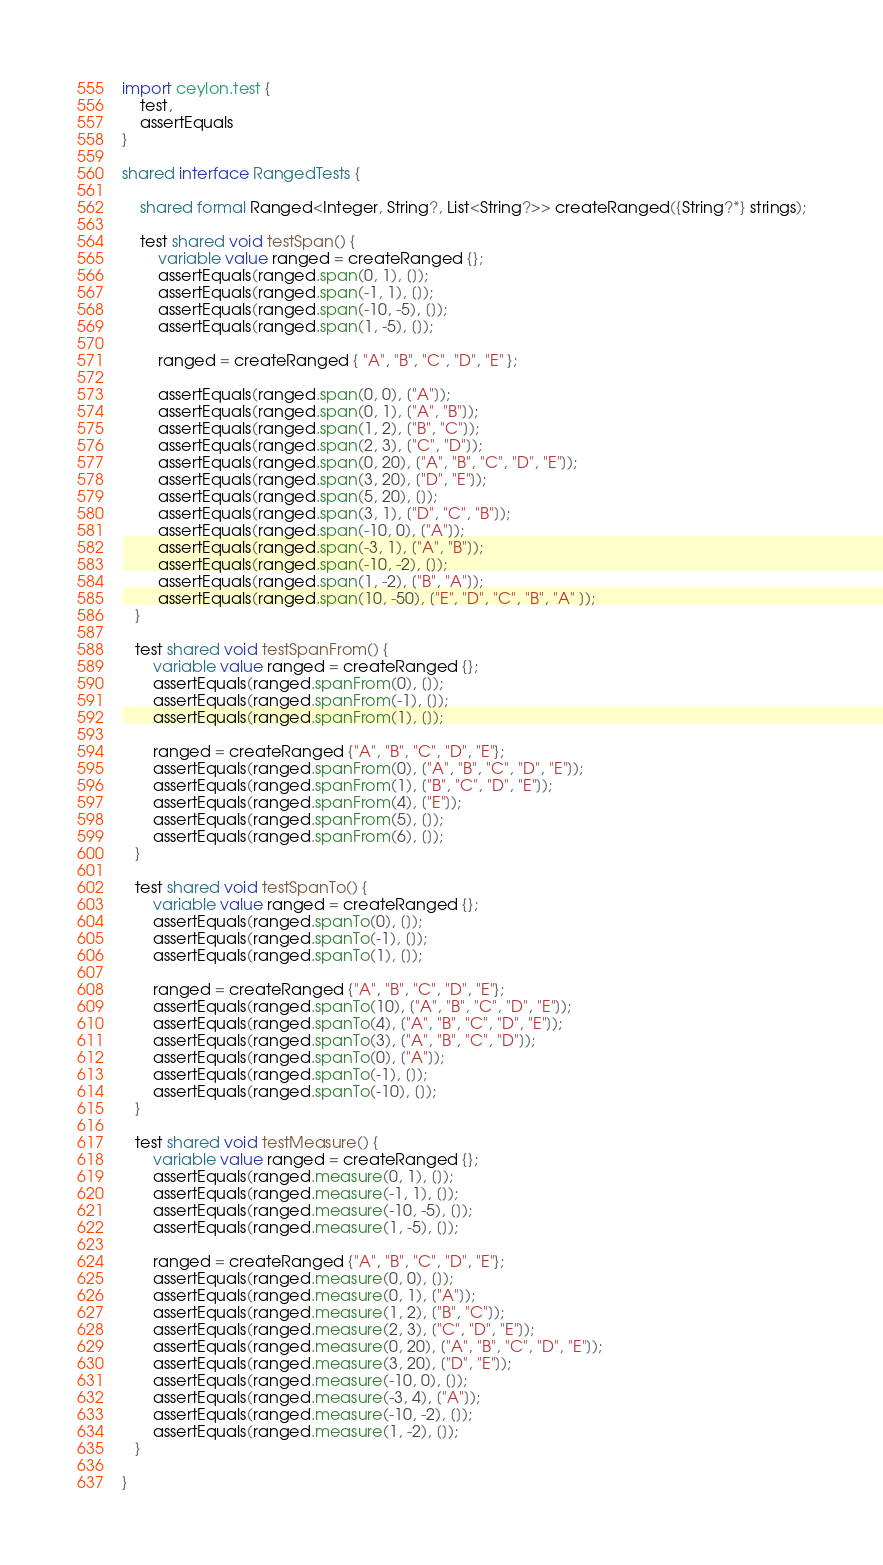Convert code to text. <code><loc_0><loc_0><loc_500><loc_500><_Ceylon_>import ceylon.test {
    test,
    assertEquals
}

shared interface RangedTests {

    shared formal Ranged<Integer, String?, List<String?>> createRanged({String?*} strings);

    test shared void testSpan() {
        variable value ranged = createRanged {};
        assertEquals(ranged.span(0, 1), []);
        assertEquals(ranged.span(-1, 1), []);
        assertEquals(ranged.span(-10, -5), []);
        assertEquals(ranged.span(1, -5), []);

        ranged = createRanged { "A", "B", "C", "D", "E" };

        assertEquals(ranged.span(0, 0), ["A"]);
        assertEquals(ranged.span(0, 1), ["A", "B"]);
        assertEquals(ranged.span(1, 2), ["B", "C"]);
        assertEquals(ranged.span(2, 3), ["C", "D"]);
        assertEquals(ranged.span(0, 20), ["A", "B", "C", "D", "E"]);
        assertEquals(ranged.span(3, 20), ["D", "E"]);
        assertEquals(ranged.span(5, 20), []);
        assertEquals(ranged.span(3, 1), ["D", "C", "B"]);
        assertEquals(ranged.span(-10, 0), ["A"]);
        assertEquals(ranged.span(-3, 1), ["A", "B"]);
        assertEquals(ranged.span(-10, -2), []);
        assertEquals(ranged.span(1, -2), ["B", "A"]);
        assertEquals(ranged.span(10, -50), ["E", "D", "C", "B", "A" ]);
   }

   test shared void testSpanFrom() {
       variable value ranged = createRanged {};
       assertEquals(ranged.spanFrom(0), []);
       assertEquals(ranged.spanFrom(-1), []);
       assertEquals(ranged.spanFrom(1), []);

       ranged = createRanged {"A", "B", "C", "D", "E"};
       assertEquals(ranged.spanFrom(0), ["A", "B", "C", "D", "E"]);
       assertEquals(ranged.spanFrom(1), ["B", "C", "D", "E"]);
       assertEquals(ranged.spanFrom(4), ["E"]);
       assertEquals(ranged.spanFrom(5), []);
       assertEquals(ranged.spanFrom(6), []);
   }

   test shared void testSpanTo() {
       variable value ranged = createRanged {};
       assertEquals(ranged.spanTo(0), []);
       assertEquals(ranged.spanTo(-1), []);
       assertEquals(ranged.spanTo(1), []);

       ranged = createRanged {"A", "B", "C", "D", "E"};
       assertEquals(ranged.spanTo(10), ["A", "B", "C", "D", "E"]);
       assertEquals(ranged.spanTo(4), ["A", "B", "C", "D", "E"]);
       assertEquals(ranged.spanTo(3), ["A", "B", "C", "D"]);
       assertEquals(ranged.spanTo(0), ["A"]);
       assertEquals(ranged.spanTo(-1), []);
       assertEquals(ranged.spanTo(-10), []);
   }

   test shared void testMeasure() {
       variable value ranged = createRanged {};
       assertEquals(ranged.measure(0, 1), []);
       assertEquals(ranged.measure(-1, 1), []);
       assertEquals(ranged.measure(-10, -5), []);
       assertEquals(ranged.measure(1, -5), []);

       ranged = createRanged {"A", "B", "C", "D", "E"};
       assertEquals(ranged.measure(0, 0), []);
       assertEquals(ranged.measure(0, 1), ["A"]);
       assertEquals(ranged.measure(1, 2), ["B", "C"]);
       assertEquals(ranged.measure(2, 3), ["C", "D", "E"]);
       assertEquals(ranged.measure(0, 20), ["A", "B", "C", "D", "E"]);
       assertEquals(ranged.measure(3, 20), ["D", "E"]);
       assertEquals(ranged.measure(-10, 0), []);
       assertEquals(ranged.measure(-3, 4), ["A"]);
       assertEquals(ranged.measure(-10, -2), []);
       assertEquals(ranged.measure(1, -2), []);
   }

}</code> 